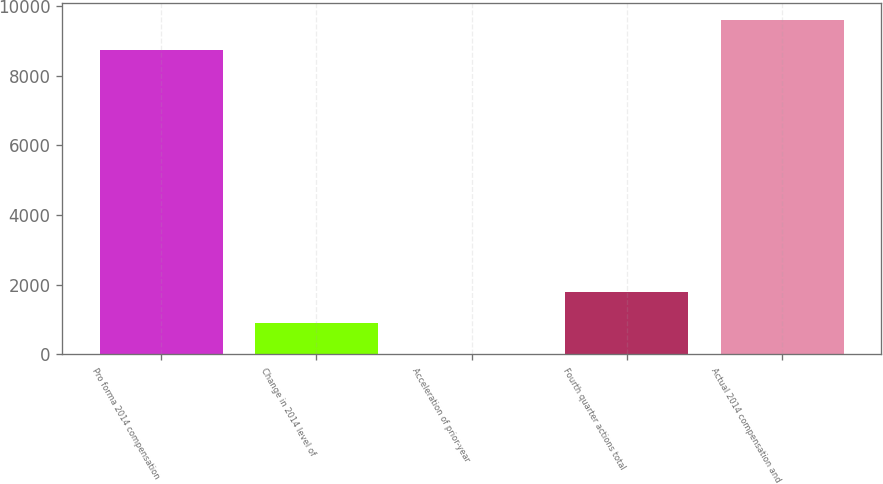Convert chart. <chart><loc_0><loc_0><loc_500><loc_500><bar_chart><fcel>Pro forma 2014 compensation<fcel>Change in 2014 level of<fcel>Acceleration of prior-year<fcel>Fourth quarter actions total<fcel>Actual 2014 compensation and<nl><fcel>8737<fcel>902.3<fcel>22<fcel>1782.6<fcel>9617.3<nl></chart> 